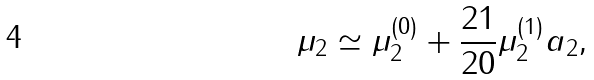<formula> <loc_0><loc_0><loc_500><loc_500>\mu _ { 2 } \simeq \mu _ { 2 } ^ { ( 0 ) } + \frac { 2 1 } { 2 0 } \mu _ { 2 } ^ { ( 1 ) } a _ { 2 } ,</formula> 